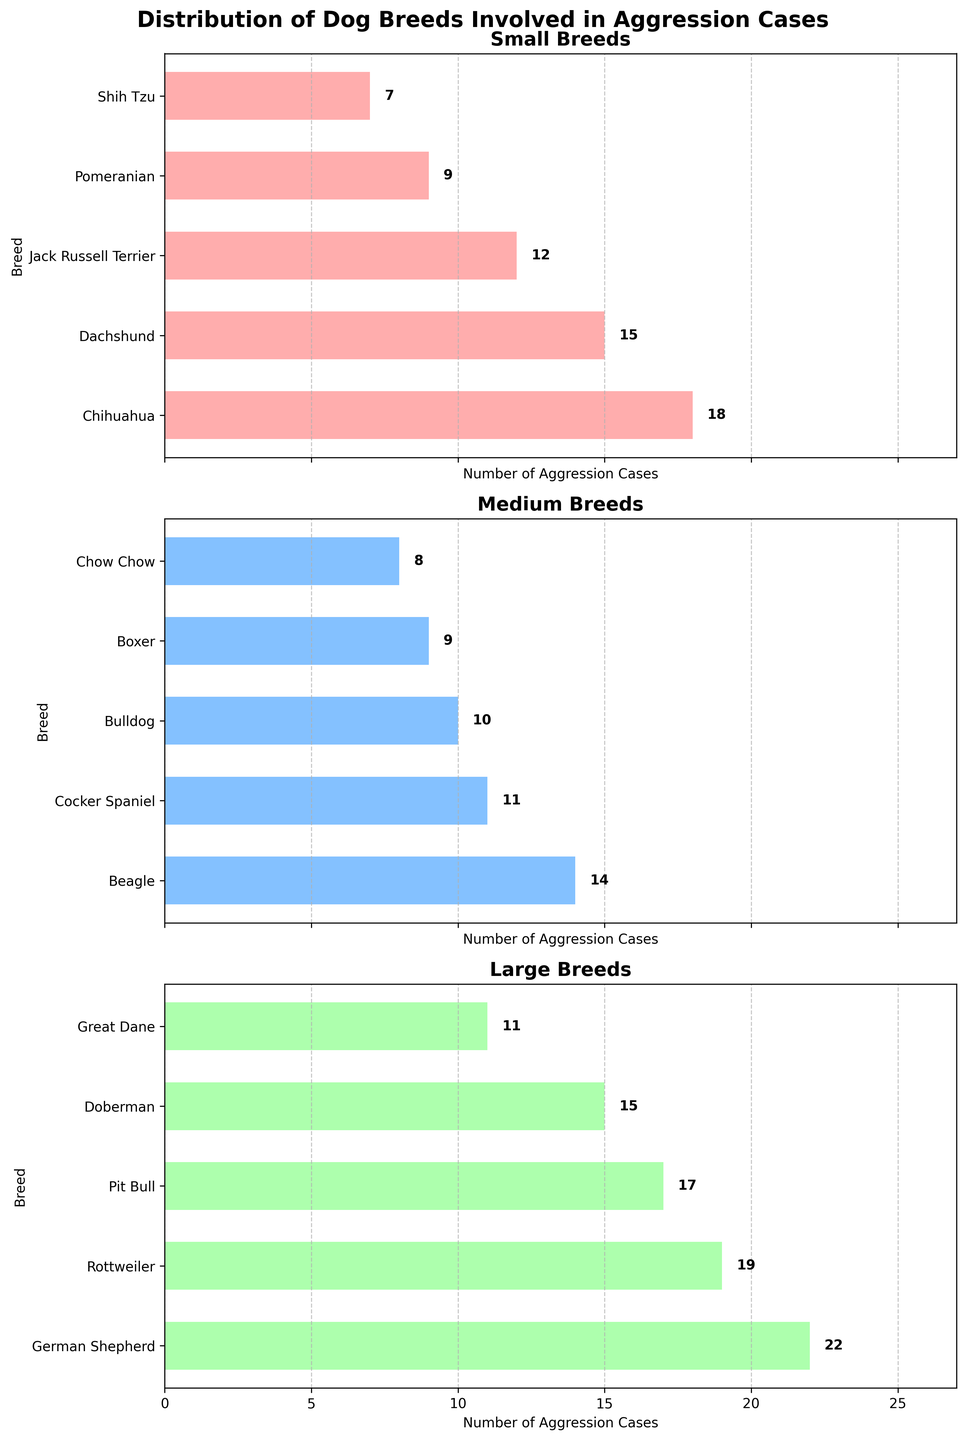What breed has the highest number of aggression cases among large breeds? The German Shepherd has the longest bar corresponding to the large size category, indicating it has the highest number of aggression cases.
Answer: German Shepherd How many total medium breeds are involved in aggression cases? Summing the bar heights for each breed in the Medium subplot: 14 (Beagle) + 11 (Cocker Spaniel) + 10 (Bulldog) + 9 (Boxer) + 8 (Chow Chow) = 52.
Answer: 52 Among the small breeds, which breed has the fewest aggression cases? The Shih Tzu has the shortest bar in the Small subplot, indicating it has the fewest aggression cases.
Answer: Shih Tzu Compare the number of aggression cases between the Pit Bull and the Great Dane. Which is higher? The Pit Bull has a longer bar (17) compared to the Great Dane (11) in the Large subplot, so the Pit Bull has more aggression cases.
Answer: Pit Bull Sum the total number of aggression cases for the top 3 small breeds. Adding the cases for the top 3 small breeds: Chihuahua (18) + Dachshund (15) + Jack Russell Terrier (12) = 45.
Answer: 45 Which breed has more aggression cases, the Boxer or the Chow Chow? The bar for the Boxer is taller at 9 cases compared to the Chow Chow at 8 cases in the Medium subplot.
Answer: Boxer Find the difference in aggression cases between the Rottweiler and the Doberman. Subtracting the aggression cases of the Doberman from the Rottweiler: 19 - 15 = 4.
Answer: 4 Which breed falls in the middle of the medium breeds based on the number of aggression cases? The medium breeds ordered by number of cases are 8, 9, 10, 11, 14. The Cocker Spaniel with 11 falls in the middle.
Answer: Cocker Spaniel Is there any overlap in breeds between the small and medium categories? By comparing the breeds listed in small and medium subplots, we see that there are no common breeds between these two categories.
Answer: No What is the average number of aggression cases for large breeds? Summing the aggression cases for large breeds: 22 (German Shepherd) + 19 (Rottweiler) + 17 (Pit Bull) + 15 (Doberman) + 11 (Great Dane) = 84. Dividing by the number of large breeds (5): 84 / 5 = 16.8.
Answer: 16.8 